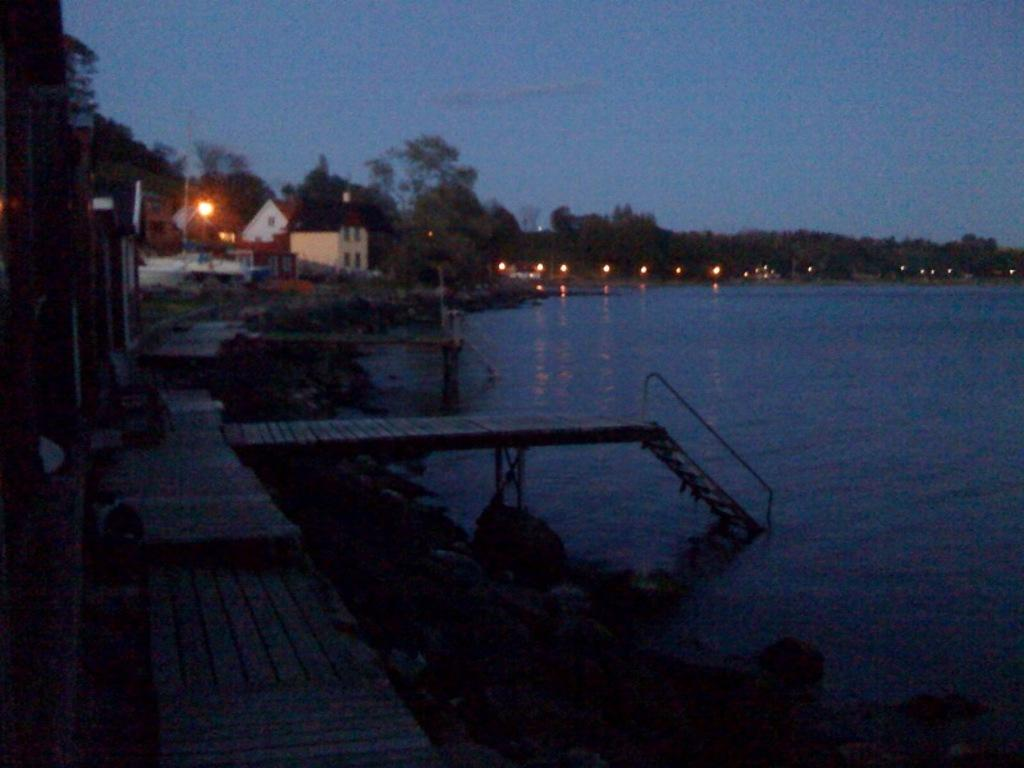What can be seen on the right side of the image? There is a water body on the right side of the image. What is located on the left side of the image? There is a dock and trailing plants on the left side of the image. What structures are present in the center of the image? There are houses, trees, and lights in the center of the image. What other objects can be found in the center of the image? There are other objects in the center of the image, but their specific details are not mentioned in the facts. What type of soda is being served on the dock? There is no mention of soda or any beverage in the image. 